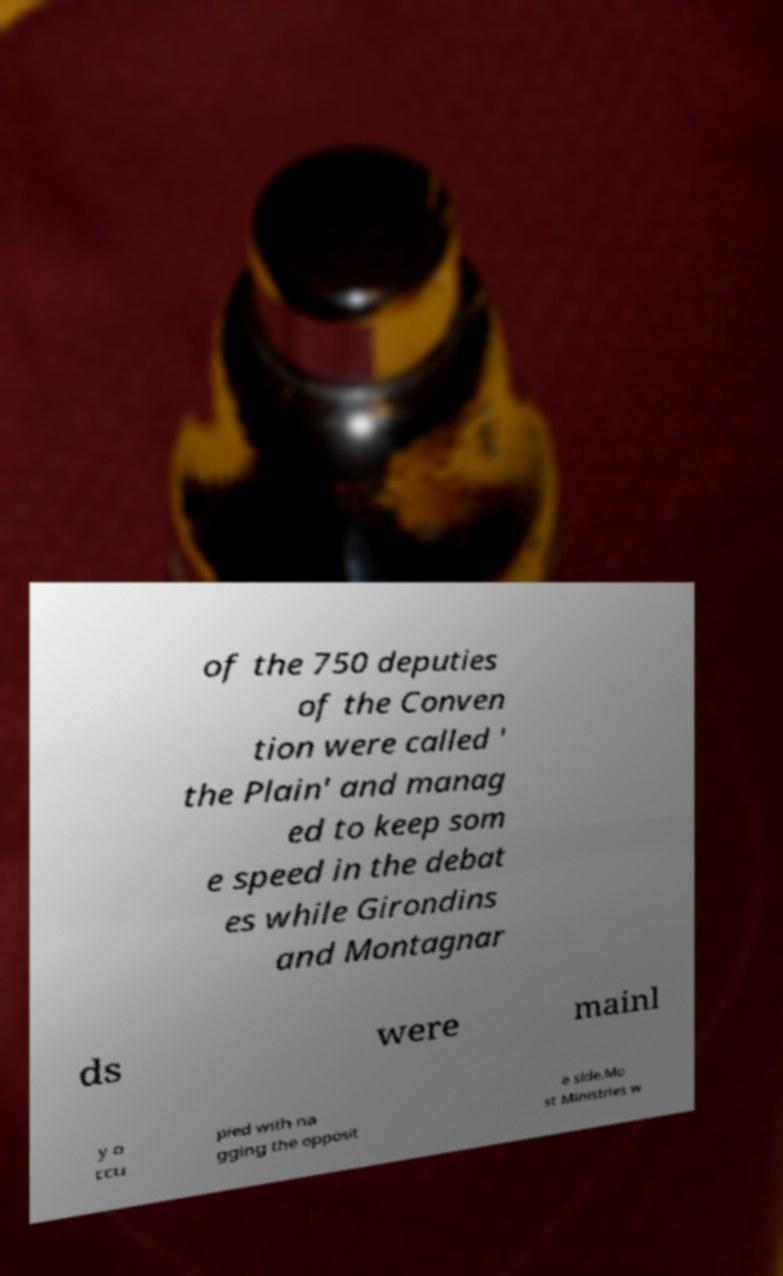Please read and relay the text visible in this image. What does it say? of the 750 deputies of the Conven tion were called ' the Plain' and manag ed to keep som e speed in the debat es while Girondins and Montagnar ds were mainl y o ccu pied with na gging the opposit e side.Mo st Ministries w 